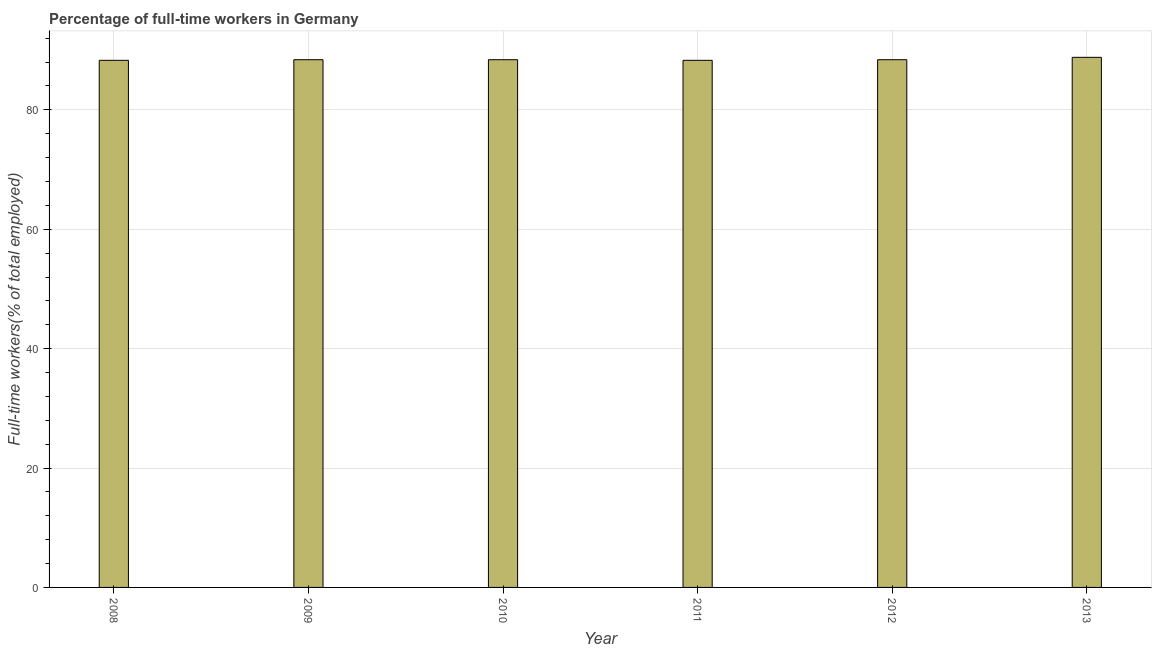Does the graph contain grids?
Keep it short and to the point. Yes. What is the title of the graph?
Give a very brief answer. Percentage of full-time workers in Germany. What is the label or title of the X-axis?
Ensure brevity in your answer.  Year. What is the label or title of the Y-axis?
Provide a succinct answer. Full-time workers(% of total employed). What is the percentage of full-time workers in 2010?
Keep it short and to the point. 88.4. Across all years, what is the maximum percentage of full-time workers?
Ensure brevity in your answer.  88.8. Across all years, what is the minimum percentage of full-time workers?
Your answer should be very brief. 88.3. In which year was the percentage of full-time workers maximum?
Ensure brevity in your answer.  2013. What is the sum of the percentage of full-time workers?
Make the answer very short. 530.6. What is the difference between the percentage of full-time workers in 2010 and 2011?
Make the answer very short. 0.1. What is the average percentage of full-time workers per year?
Your response must be concise. 88.43. What is the median percentage of full-time workers?
Your answer should be compact. 88.4. In how many years, is the percentage of full-time workers greater than 88 %?
Your answer should be very brief. 6. What is the ratio of the percentage of full-time workers in 2010 to that in 2013?
Offer a very short reply. 0.99. Is the percentage of full-time workers in 2010 less than that in 2011?
Your answer should be compact. No. What is the difference between the highest and the second highest percentage of full-time workers?
Offer a very short reply. 0.4. In how many years, is the percentage of full-time workers greater than the average percentage of full-time workers taken over all years?
Make the answer very short. 1. How many bars are there?
Your answer should be compact. 6. Are all the bars in the graph horizontal?
Keep it short and to the point. No. What is the difference between two consecutive major ticks on the Y-axis?
Your answer should be very brief. 20. What is the Full-time workers(% of total employed) of 2008?
Provide a short and direct response. 88.3. What is the Full-time workers(% of total employed) in 2009?
Offer a very short reply. 88.4. What is the Full-time workers(% of total employed) of 2010?
Give a very brief answer. 88.4. What is the Full-time workers(% of total employed) in 2011?
Offer a terse response. 88.3. What is the Full-time workers(% of total employed) of 2012?
Offer a terse response. 88.4. What is the Full-time workers(% of total employed) in 2013?
Give a very brief answer. 88.8. What is the difference between the Full-time workers(% of total employed) in 2008 and 2009?
Offer a terse response. -0.1. What is the difference between the Full-time workers(% of total employed) in 2008 and 2010?
Keep it short and to the point. -0.1. What is the difference between the Full-time workers(% of total employed) in 2008 and 2012?
Provide a succinct answer. -0.1. What is the difference between the Full-time workers(% of total employed) in 2008 and 2013?
Ensure brevity in your answer.  -0.5. What is the difference between the Full-time workers(% of total employed) in 2009 and 2010?
Provide a succinct answer. 0. What is the difference between the Full-time workers(% of total employed) in 2009 and 2013?
Provide a succinct answer. -0.4. What is the difference between the Full-time workers(% of total employed) in 2012 and 2013?
Your response must be concise. -0.4. What is the ratio of the Full-time workers(% of total employed) in 2008 to that in 2011?
Keep it short and to the point. 1. What is the ratio of the Full-time workers(% of total employed) in 2008 to that in 2012?
Ensure brevity in your answer.  1. What is the ratio of the Full-time workers(% of total employed) in 2008 to that in 2013?
Provide a succinct answer. 0.99. What is the ratio of the Full-time workers(% of total employed) in 2009 to that in 2011?
Make the answer very short. 1. What is the ratio of the Full-time workers(% of total employed) in 2009 to that in 2012?
Offer a terse response. 1. What is the ratio of the Full-time workers(% of total employed) in 2010 to that in 2011?
Give a very brief answer. 1. What is the ratio of the Full-time workers(% of total employed) in 2010 to that in 2012?
Provide a short and direct response. 1. What is the ratio of the Full-time workers(% of total employed) in 2010 to that in 2013?
Your response must be concise. 0.99. 